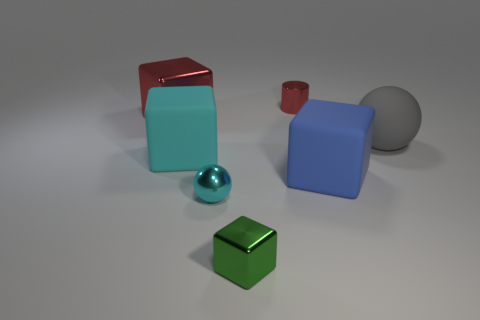How many other objects are the same material as the big blue thing?
Provide a short and direct response. 2. What number of other things are there of the same color as the large shiny cube?
Your answer should be very brief. 1. What is the material of the object behind the block behind the large gray matte sphere?
Your response must be concise. Metal. Is there a rubber cube?
Your answer should be very brief. Yes. There is a matte object that is in front of the rubber cube that is left of the blue thing; what size is it?
Provide a short and direct response. Large. Are there more tiny green things that are in front of the green metal thing than cylinders that are to the right of the large gray rubber object?
Your answer should be compact. No. How many cylinders are either blue matte objects or large red objects?
Make the answer very short. 0. Is there any other thing that is the same size as the red cylinder?
Provide a succinct answer. Yes. There is a rubber object to the left of the cyan shiny sphere; does it have the same shape as the big gray rubber thing?
Your answer should be very brief. No. What color is the tiny sphere?
Give a very brief answer. Cyan. 